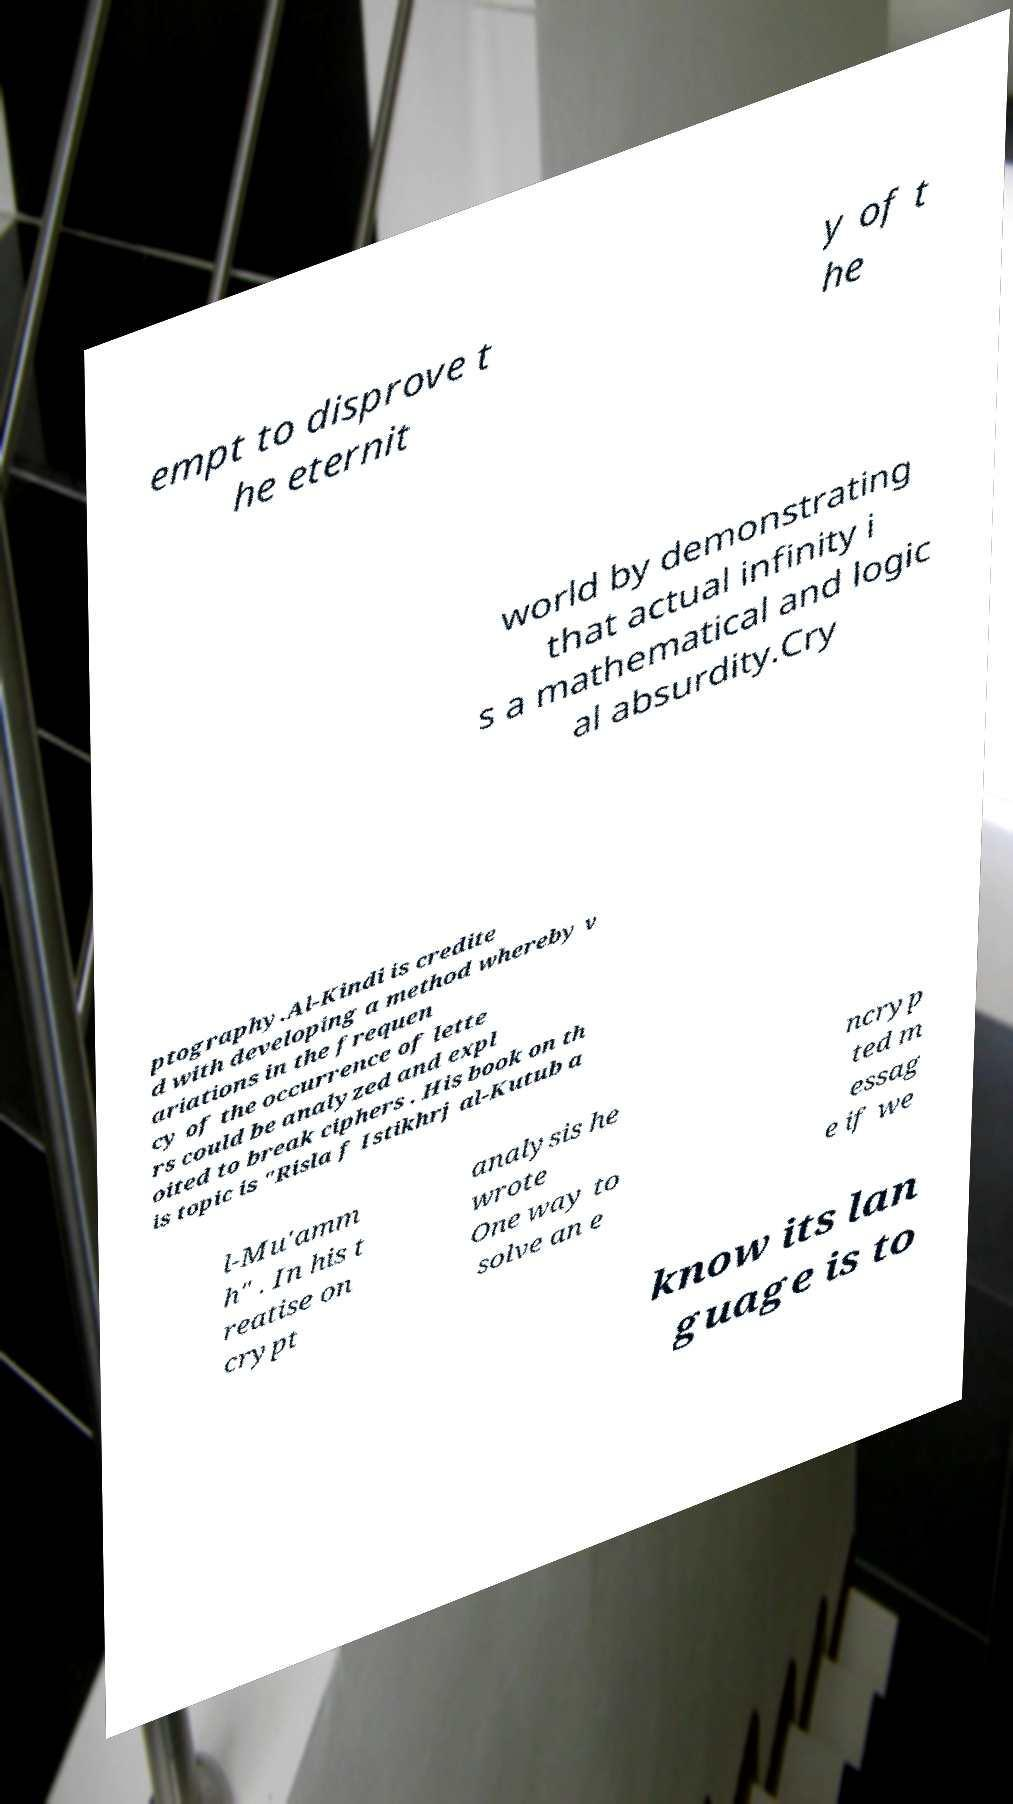Can you accurately transcribe the text from the provided image for me? empt to disprove t he eternit y of t he world by demonstrating that actual infinity i s a mathematical and logic al absurdity.Cry ptography.Al-Kindi is credite d with developing a method whereby v ariations in the frequen cy of the occurrence of lette rs could be analyzed and expl oited to break ciphers . His book on th is topic is "Risla f Istikhrj al-Kutub a l-Mu'amm h" . In his t reatise on crypt analysis he wrote One way to solve an e ncryp ted m essag e if we know its lan guage is to 